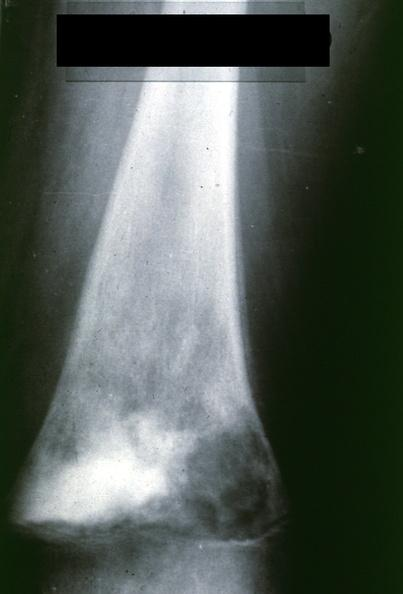what is present?
Answer the question using a single word or phrase. Joints 